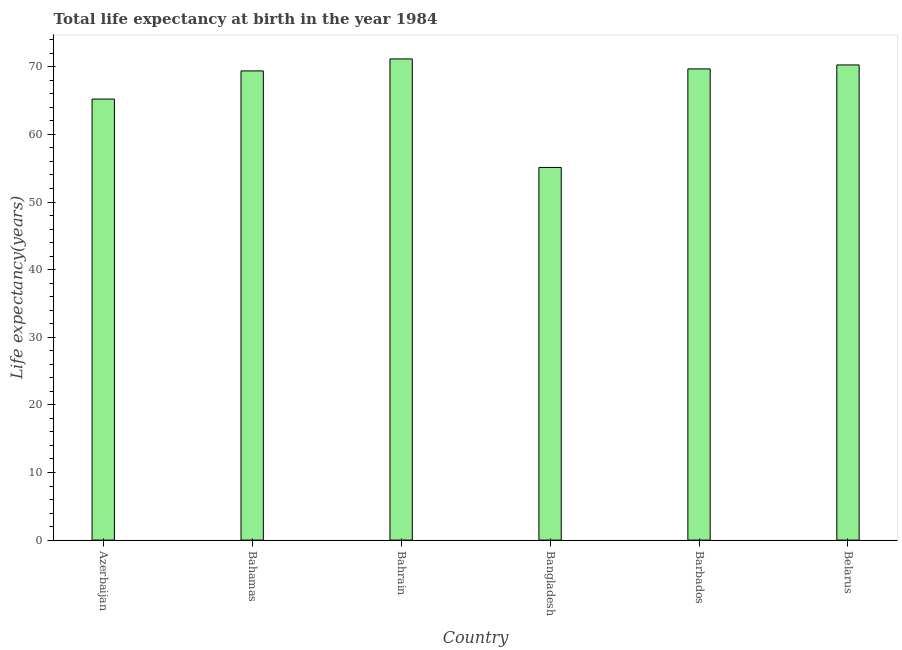Does the graph contain any zero values?
Your answer should be compact. No. Does the graph contain grids?
Make the answer very short. No. What is the title of the graph?
Provide a succinct answer. Total life expectancy at birth in the year 1984. What is the label or title of the Y-axis?
Ensure brevity in your answer.  Life expectancy(years). What is the life expectancy at birth in Belarus?
Your response must be concise. 70.27. Across all countries, what is the maximum life expectancy at birth?
Make the answer very short. 71.16. Across all countries, what is the minimum life expectancy at birth?
Provide a short and direct response. 55.11. In which country was the life expectancy at birth maximum?
Your answer should be compact. Bahrain. In which country was the life expectancy at birth minimum?
Offer a very short reply. Bangladesh. What is the sum of the life expectancy at birth?
Offer a very short reply. 400.84. What is the difference between the life expectancy at birth in Bahrain and Barbados?
Make the answer very short. 1.48. What is the average life expectancy at birth per country?
Give a very brief answer. 66.81. What is the median life expectancy at birth?
Provide a succinct answer. 69.54. What is the ratio of the life expectancy at birth in Bahrain to that in Belarus?
Ensure brevity in your answer.  1.01. Is the life expectancy at birth in Barbados less than that in Belarus?
Provide a succinct answer. Yes. Is the difference between the life expectancy at birth in Azerbaijan and Bahrain greater than the difference between any two countries?
Your answer should be very brief. No. What is the difference between the highest and the second highest life expectancy at birth?
Your response must be concise. 0.89. Is the sum of the life expectancy at birth in Azerbaijan and Barbados greater than the maximum life expectancy at birth across all countries?
Offer a terse response. Yes. What is the difference between the highest and the lowest life expectancy at birth?
Provide a short and direct response. 16.05. In how many countries, is the life expectancy at birth greater than the average life expectancy at birth taken over all countries?
Offer a very short reply. 4. How many countries are there in the graph?
Offer a very short reply. 6. What is the difference between two consecutive major ticks on the Y-axis?
Offer a terse response. 10. Are the values on the major ticks of Y-axis written in scientific E-notation?
Make the answer very short. No. What is the Life expectancy(years) of Azerbaijan?
Give a very brief answer. 65.23. What is the Life expectancy(years) of Bahamas?
Provide a succinct answer. 69.39. What is the Life expectancy(years) in Bahrain?
Provide a succinct answer. 71.16. What is the Life expectancy(years) in Bangladesh?
Provide a short and direct response. 55.11. What is the Life expectancy(years) of Barbados?
Your response must be concise. 69.68. What is the Life expectancy(years) of Belarus?
Offer a very short reply. 70.27. What is the difference between the Life expectancy(years) in Azerbaijan and Bahamas?
Give a very brief answer. -4.16. What is the difference between the Life expectancy(years) in Azerbaijan and Bahrain?
Your response must be concise. -5.93. What is the difference between the Life expectancy(years) in Azerbaijan and Bangladesh?
Your answer should be compact. 10.11. What is the difference between the Life expectancy(years) in Azerbaijan and Barbados?
Make the answer very short. -4.46. What is the difference between the Life expectancy(years) in Azerbaijan and Belarus?
Offer a very short reply. -5.05. What is the difference between the Life expectancy(years) in Bahamas and Bahrain?
Your answer should be very brief. -1.77. What is the difference between the Life expectancy(years) in Bahamas and Bangladesh?
Provide a succinct answer. 14.27. What is the difference between the Life expectancy(years) in Bahamas and Barbados?
Provide a short and direct response. -0.3. What is the difference between the Life expectancy(years) in Bahamas and Belarus?
Offer a terse response. -0.88. What is the difference between the Life expectancy(years) in Bahrain and Bangladesh?
Provide a succinct answer. 16.05. What is the difference between the Life expectancy(years) in Bahrain and Barbados?
Give a very brief answer. 1.48. What is the difference between the Life expectancy(years) in Bahrain and Belarus?
Keep it short and to the point. 0.89. What is the difference between the Life expectancy(years) in Bangladesh and Barbados?
Offer a very short reply. -14.57. What is the difference between the Life expectancy(years) in Bangladesh and Belarus?
Offer a terse response. -15.16. What is the difference between the Life expectancy(years) in Barbados and Belarus?
Give a very brief answer. -0.59. What is the ratio of the Life expectancy(years) in Azerbaijan to that in Bahamas?
Your answer should be very brief. 0.94. What is the ratio of the Life expectancy(years) in Azerbaijan to that in Bahrain?
Provide a short and direct response. 0.92. What is the ratio of the Life expectancy(years) in Azerbaijan to that in Bangladesh?
Your answer should be compact. 1.18. What is the ratio of the Life expectancy(years) in Azerbaijan to that in Barbados?
Ensure brevity in your answer.  0.94. What is the ratio of the Life expectancy(years) in Azerbaijan to that in Belarus?
Ensure brevity in your answer.  0.93. What is the ratio of the Life expectancy(years) in Bahamas to that in Bahrain?
Make the answer very short. 0.97. What is the ratio of the Life expectancy(years) in Bahamas to that in Bangladesh?
Your answer should be compact. 1.26. What is the ratio of the Life expectancy(years) in Bahrain to that in Bangladesh?
Offer a very short reply. 1.29. What is the ratio of the Life expectancy(years) in Bahrain to that in Barbados?
Provide a succinct answer. 1.02. What is the ratio of the Life expectancy(years) in Bahrain to that in Belarus?
Make the answer very short. 1.01. What is the ratio of the Life expectancy(years) in Bangladesh to that in Barbados?
Make the answer very short. 0.79. What is the ratio of the Life expectancy(years) in Bangladesh to that in Belarus?
Provide a succinct answer. 0.78. What is the ratio of the Life expectancy(years) in Barbados to that in Belarus?
Your answer should be very brief. 0.99. 